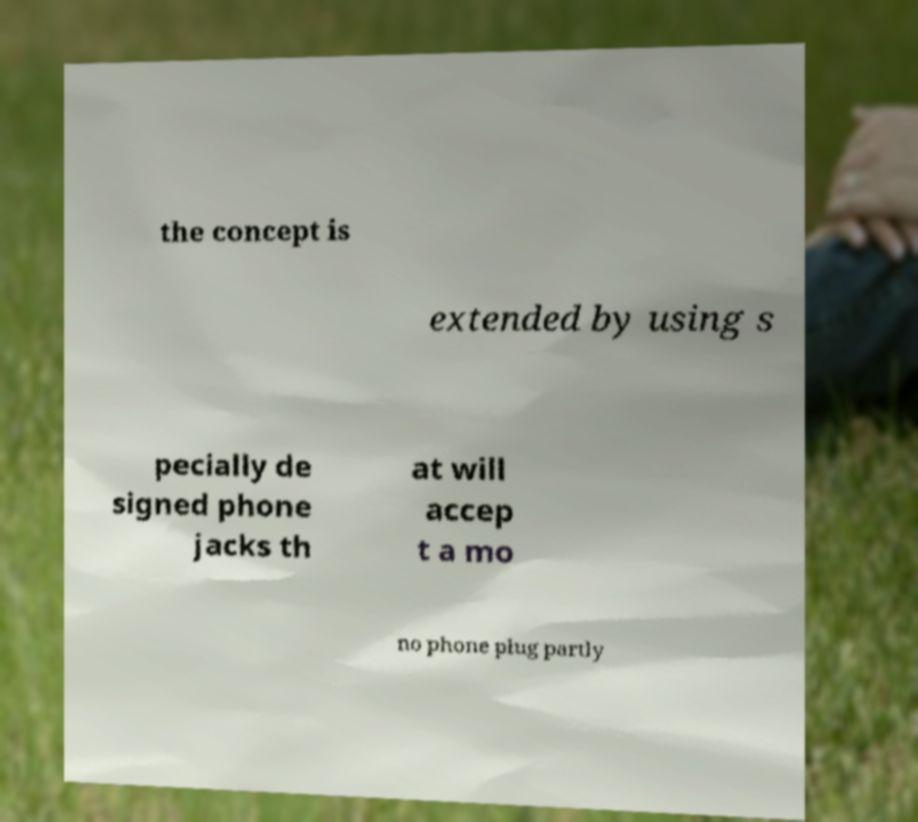Please read and relay the text visible in this image. What does it say? the concept is extended by using s pecially de signed phone jacks th at will accep t a mo no phone plug partly 